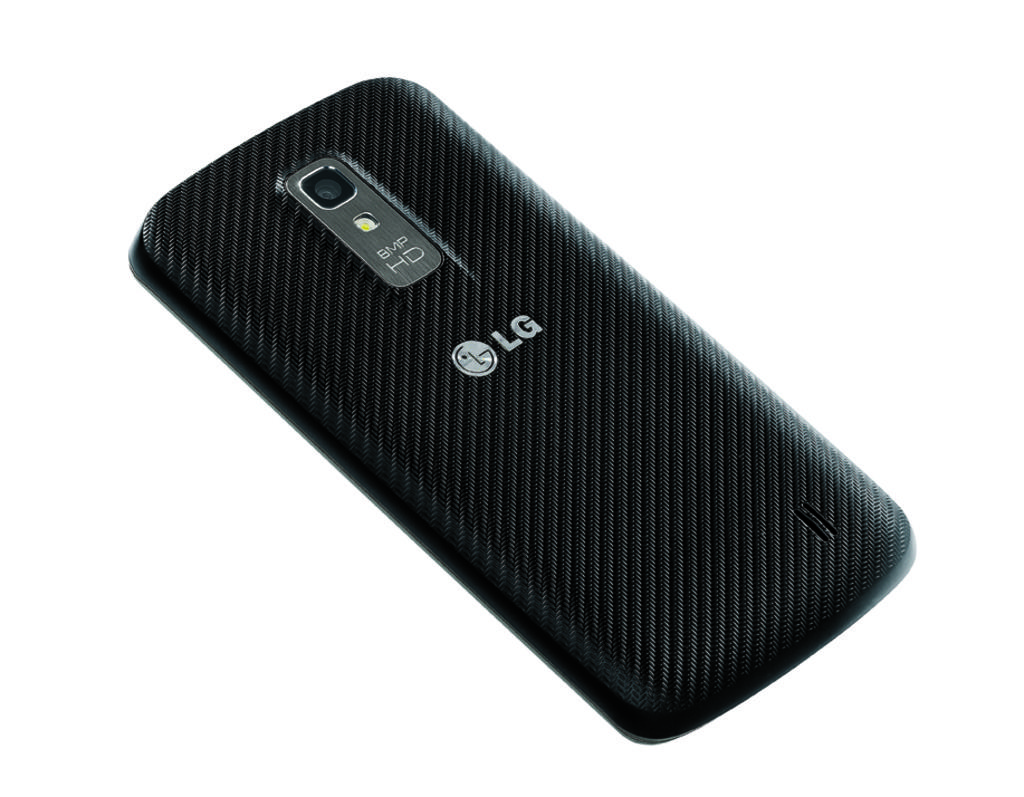What is the color of the mobile phone in the image? The mobile phone is black in color. What type of bird is flying over the mobile phone in the image? There is no bird present in the image; it only features a black mobile phone. 